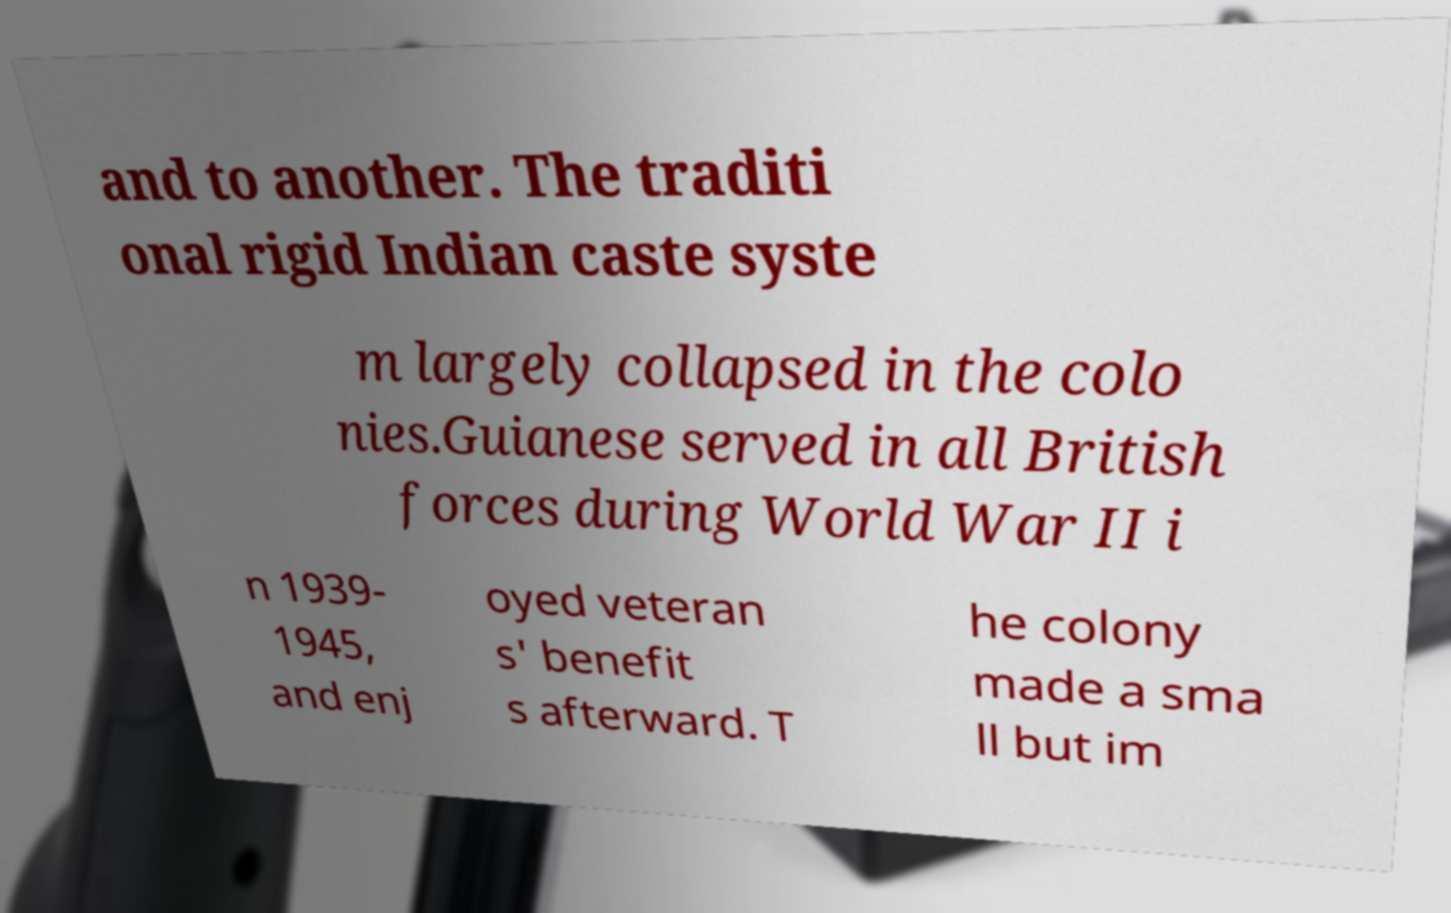I need the written content from this picture converted into text. Can you do that? and to another. The traditi onal rigid Indian caste syste m largely collapsed in the colo nies.Guianese served in all British forces during World War II i n 1939- 1945, and enj oyed veteran s' benefit s afterward. T he colony made a sma ll but im 